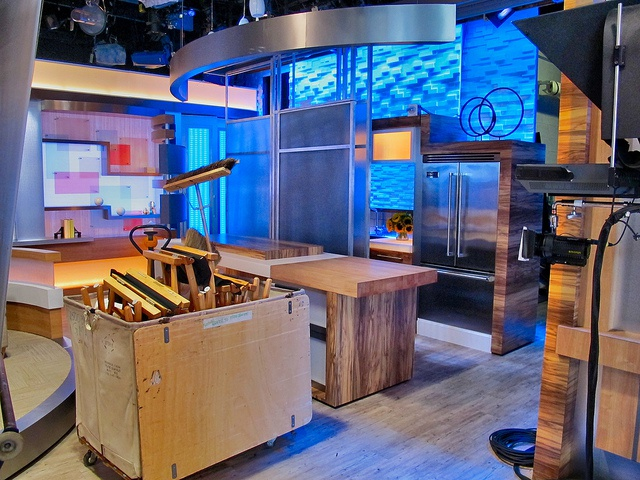Describe the objects in this image and their specific colors. I can see refrigerator in black, navy, purple, and gray tones and vase in black, maroon, brown, lightpink, and gray tones in this image. 